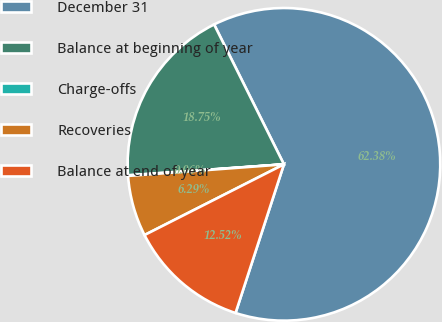<chart> <loc_0><loc_0><loc_500><loc_500><pie_chart><fcel>December 31<fcel>Balance at beginning of year<fcel>Charge-offs<fcel>Recoveries<fcel>Balance at end of year<nl><fcel>62.37%<fcel>18.75%<fcel>0.06%<fcel>6.29%<fcel>12.52%<nl></chart> 